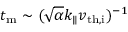<formula> <loc_0><loc_0><loc_500><loc_500>t _ { m } \sim ( \sqrt { \alpha } k _ { \| } v _ { t h , i } ) ^ { - 1 }</formula> 